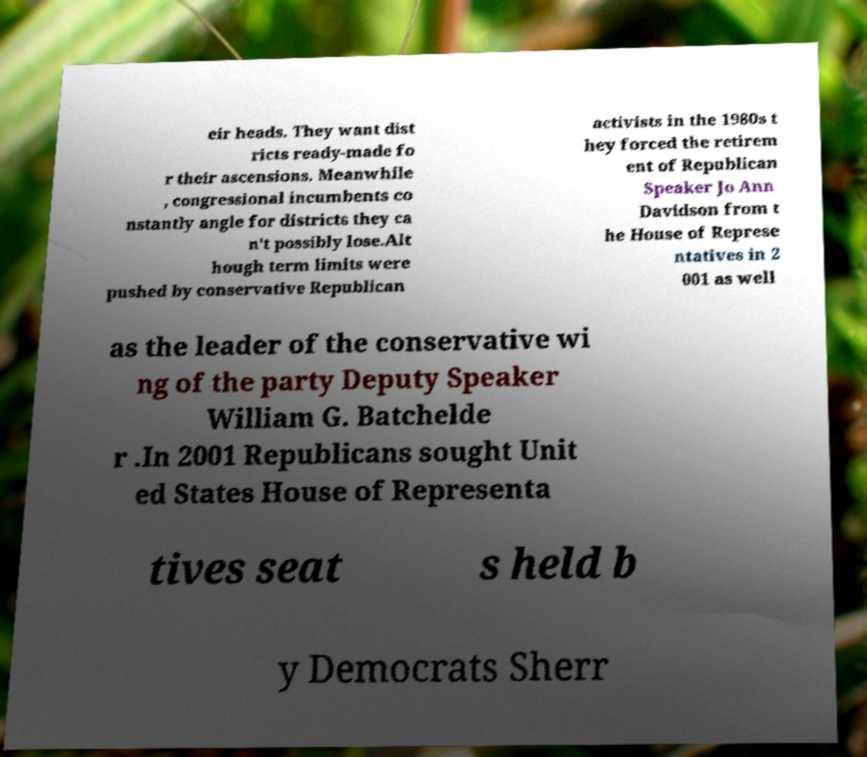Please read and relay the text visible in this image. What does it say? eir heads. They want dist ricts ready-made fo r their ascensions. Meanwhile , congressional incumbents co nstantly angle for districts they ca n't possibly lose.Alt hough term limits were pushed by conservative Republican activists in the 1980s t hey forced the retirem ent of Republican Speaker Jo Ann Davidson from t he House of Represe ntatives in 2 001 as well as the leader of the conservative wi ng of the party Deputy Speaker William G. Batchelde r .In 2001 Republicans sought Unit ed States House of Representa tives seat s held b y Democrats Sherr 